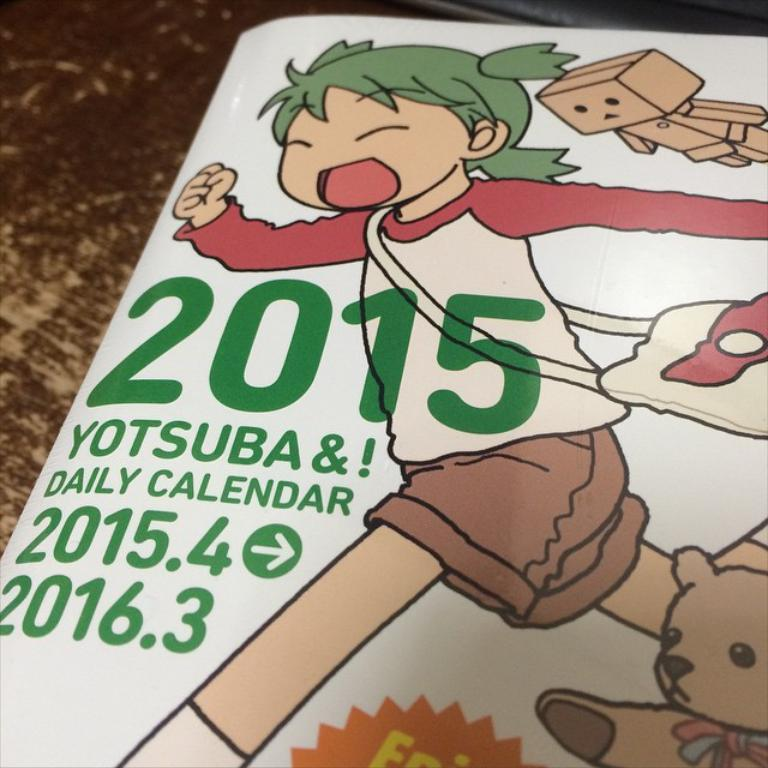What is the main subject of the image? There is a picture of a kid in the image. What else can be seen in the image besides the kid? There is a text written on a paper in the image. What is the setting of the image? The background of the image appears to be a floor. What type of bomb is visible in the image? There is no bomb present in the image. How does the water affect the purpose of the image? There is no water present in the image, so its purpose is not affected by water. 